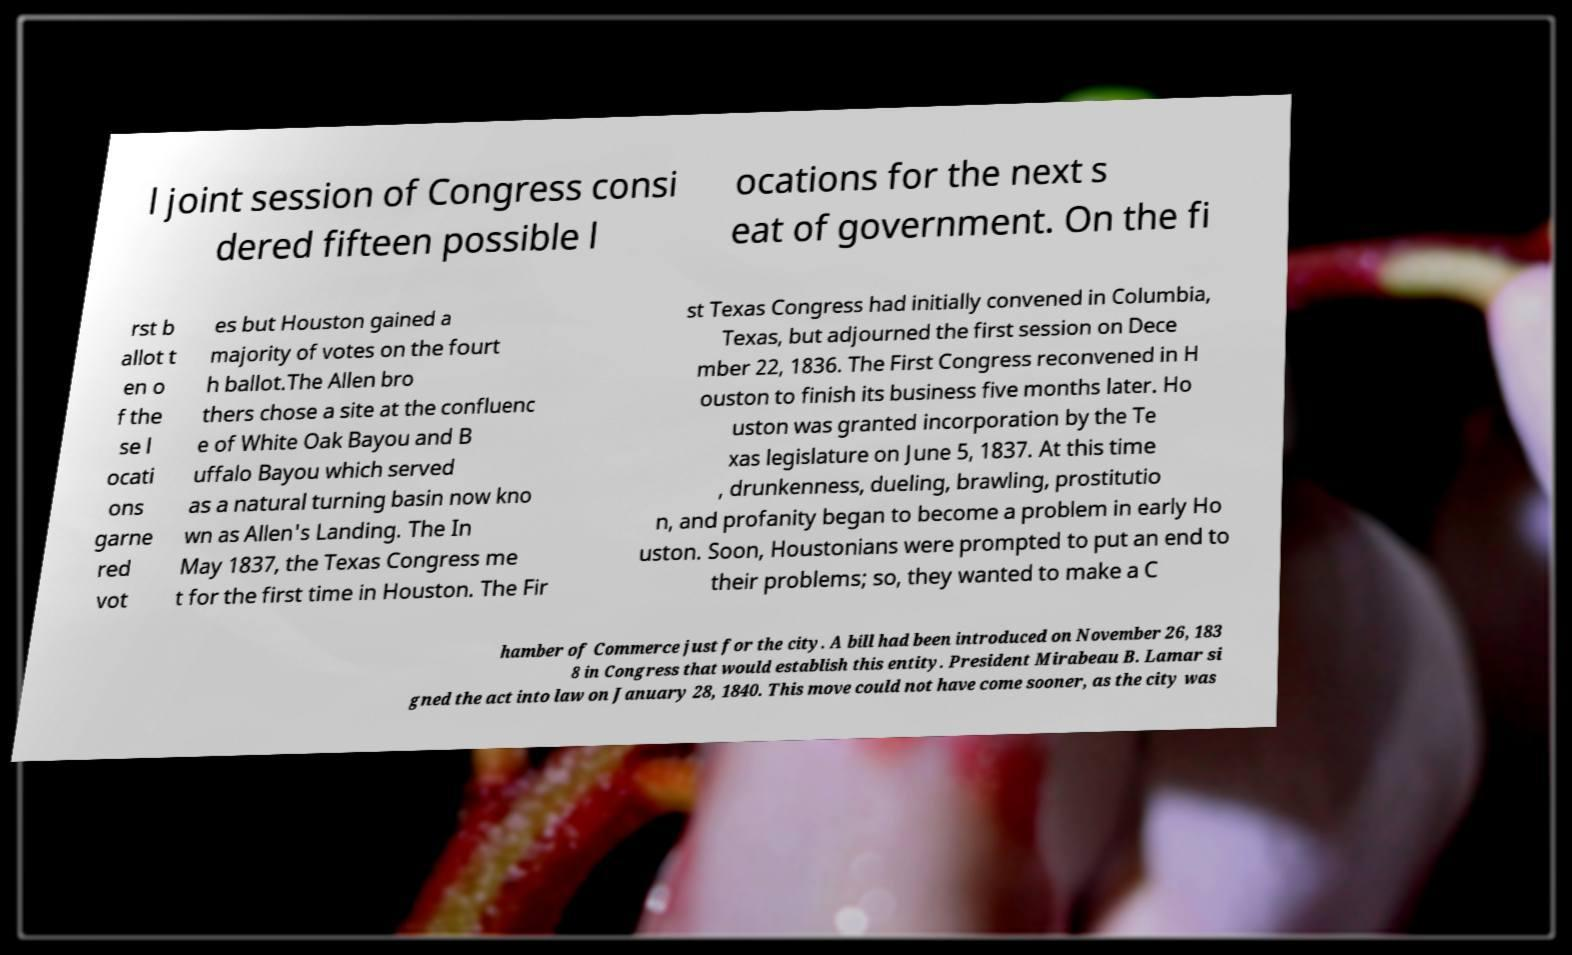For documentation purposes, I need the text within this image transcribed. Could you provide that? l joint session of Congress consi dered fifteen possible l ocations for the next s eat of government. On the fi rst b allot t en o f the se l ocati ons garne red vot es but Houston gained a majority of votes on the fourt h ballot.The Allen bro thers chose a site at the confluenc e of White Oak Bayou and B uffalo Bayou which served as a natural turning basin now kno wn as Allen's Landing. The In May 1837, the Texas Congress me t for the first time in Houston. The Fir st Texas Congress had initially convened in Columbia, Texas, but adjourned the first session on Dece mber 22, 1836. The First Congress reconvened in H ouston to finish its business five months later. Ho uston was granted incorporation by the Te xas legislature on June 5, 1837. At this time , drunkenness, dueling, brawling, prostitutio n, and profanity began to become a problem in early Ho uston. Soon, Houstonians were prompted to put an end to their problems; so, they wanted to make a C hamber of Commerce just for the city. A bill had been introduced on November 26, 183 8 in Congress that would establish this entity. President Mirabeau B. Lamar si gned the act into law on January 28, 1840. This move could not have come sooner, as the city was 